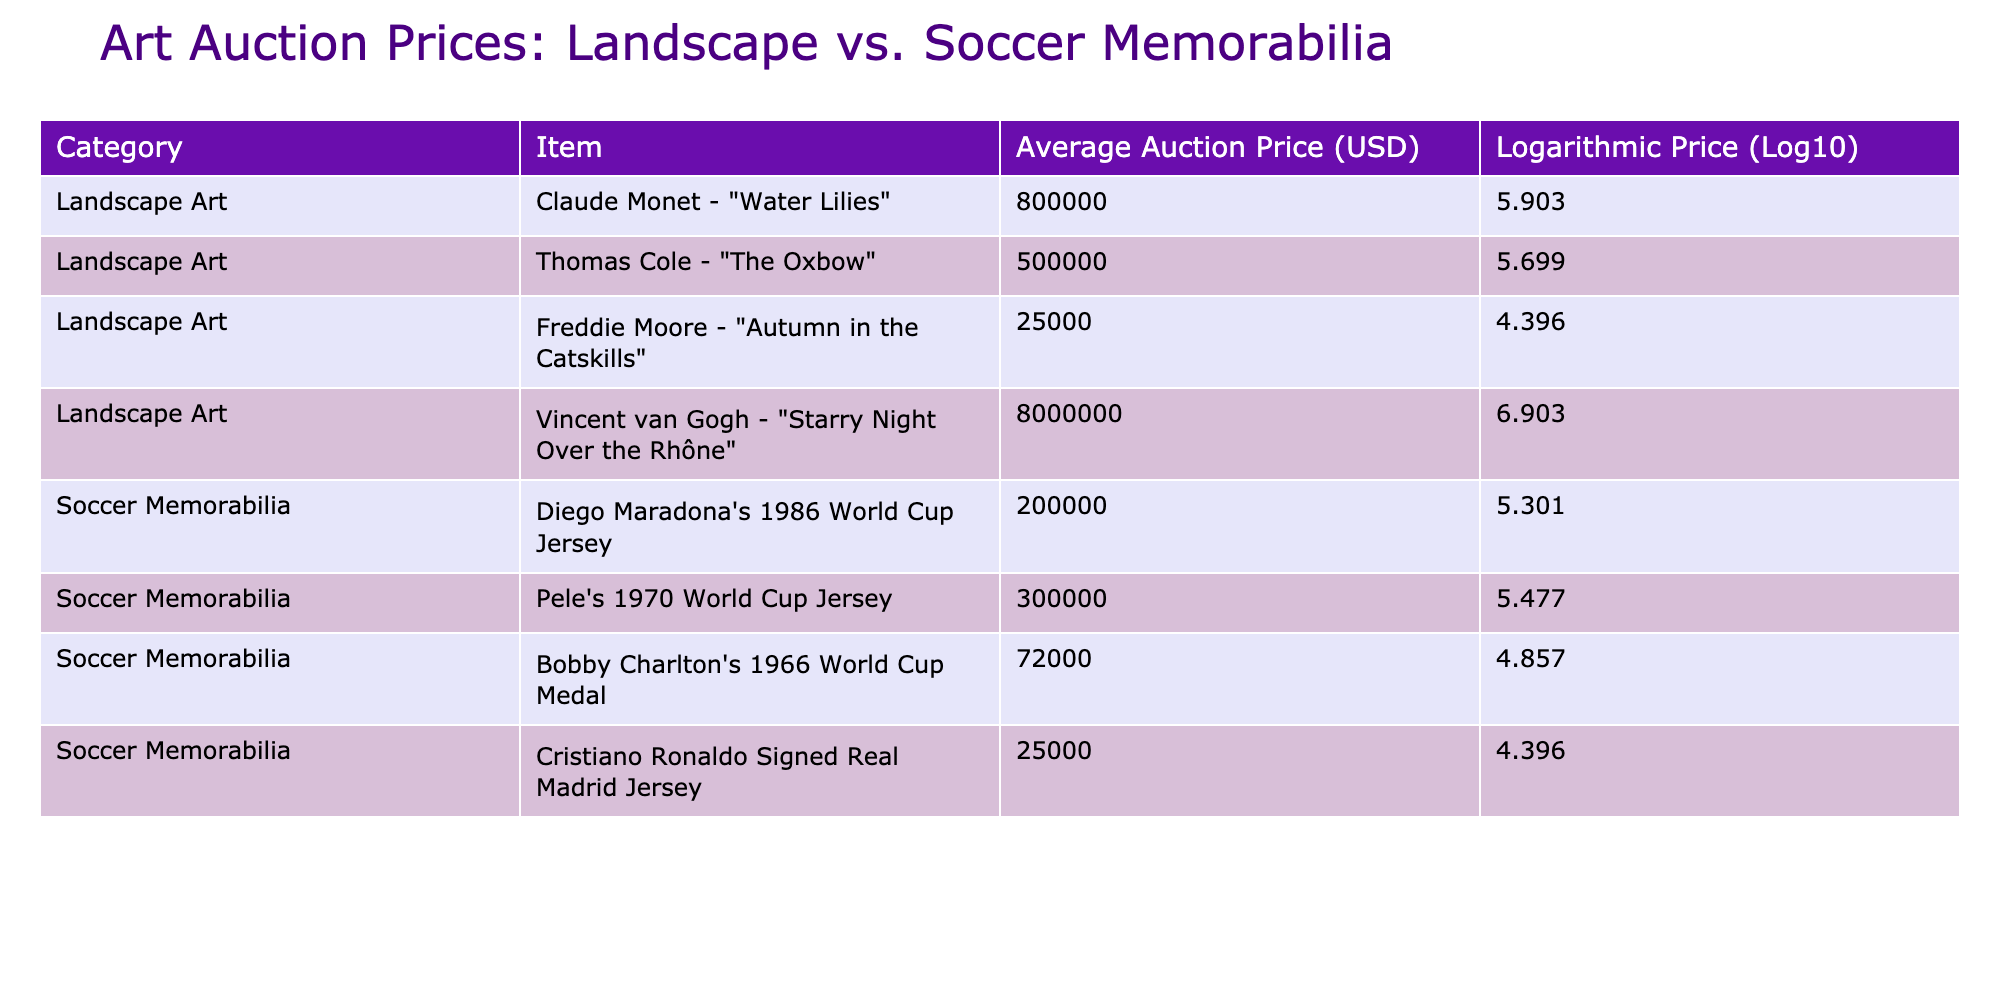What is the average auction price for Landscape Art? The auction prices for Landscape Art are 800000, 500000, 25000, and 8000000. To find the average, sum these values: 800000 + 500000 + 25000 + 8000000 = 9325000. There are 4 items, so the average is 9325000 / 4 = 2331250.
Answer: 2331250 Which item has the highest logarithmic price among Soccer Memorabilia? The logarithmic prices for Soccer Memorabilia are 5.301, 5.477, 4.857, and 4.396. The highest value is 5.477 for Pele's 1970 World Cup Jersey.
Answer: Pele's 1970 World Cup Jersey Is the average auction price of Landscape Art higher than that of Soccer Memorabilia? The average auction price for Landscape Art is calculated to be 2331250. For Soccer Memorabilia, the prices are 200000, 300000, 72000, and 25000, which sum to 527072 and with 4 items gives an average of 527072 / 4 = 131768. The average for Landscape Art is higher than that for Soccer Memorabilia.
Answer: Yes What is the difference in logarithmic values between the highest and lowest auction price for Landscape Art? The highest logarithmic value for Landscape Art is 6.903 (Vincent van Gogh) and the lowest is 4.396 (Freddie Moore). The difference is 6.903 - 4.396 = 2.507.
Answer: 2.507 How many Soccer Memorabilia items have an average auction price below 100000? The auction prices for Soccer Memorabilia are 200000, 300000, 72000, and 25000. The items with prices below 100000 are 72000 and 25000, giving a count of 2.
Answer: 2 Which category has more total auction value when considering all items? The total auction value for Landscape Art is 9325000 and for Soccer Memorabilia is 527072. To compare, we see that 9325000 > 527072, indicating that Landscape Art has more total auction value.
Answer: Landscape Art Is there any Soccer Memorabilia item whose auction price is the same as that of the lowest Landscape Art item? The lowest auction price for Landscape Art is 25000 from Freddie Moore. The Soccer Memorabilia prices are 200000, 300000, 72000, and 25000. Since 25000 matches one item, it confirms that there is one match.
Answer: Yes What is the total auction price for all items in Landscape Art? The total auction price for Landscape Art is found by adding the prices: 800000 + 500000 + 25000 + 8000000 = 9325000.
Answer: 9325000 